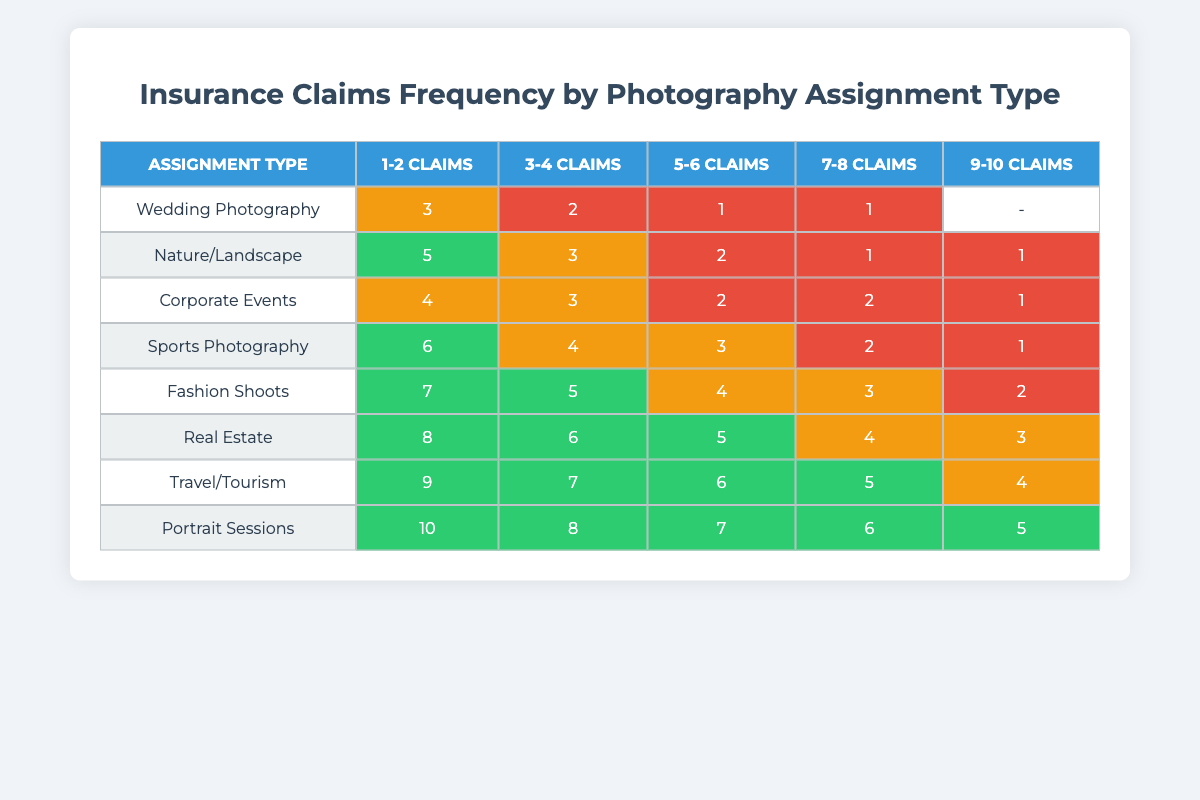What is the highest claim frequency for Wedding Photography? The table shows a maximum frequency of 10 claims for Wedding Photography, which is displayed in the row corresponding to Wedding Photography under the "9-10 Claims" column.
Answer: 10 Which type of photography assignment has the lowest claim frequency? The lowest claim frequency appears to be for Fashion Shoots, where the maximum is 1 claim in the "7-8 Claims" column, and no claims were reported in the higher frequency categories.
Answer: Fashion Shoots How many assignment types have at least 5 claims? By inspecting the table, it is noted that Nature/Landscape, Corporate Events, Sports Photography, Fashion Shoots, Real Estate, Travel/Tourism, and Portrait Sessions have frequencies where the maximum is below 5 claims, except for Wedding Photography which has a maximum of 10 claims in the last column. This means only Wedding Photography meets this criterion.
Answer: 1 What is the total number of claims made for Sports Photography? The values for Sports Photography in the table are 2 (1-2 Claims), 2 (3-4 Claims), 1 (5-6 Claims), 1 (7-8 Claims), and 0 (9-10 Claims). Adding these gives a total of 2 + 2 + 1 + 1 + 0 = 6 claims.
Answer: 6 Is it true that Corporate Events has a higher claim frequency than Nature/Landscape? We compare the highest claim frequencies between Corporate Events and Nature/Landscape. Corporate Events has a maximum of 4 claims, while Nature/Landscape has a maximum of 5 claims. Since 4 is not greater than 5, the statement is false.
Answer: No What is the average frequency of claims across all assignment types in the "5-6 Claims" category? The values for the "5-6 Claims" category are: 1 (Wedding Photography), 2 (Nature/Landscape), 2 (Corporate Events), 3 (Sports Photography), 4 (Fashion Shoots), 5 (Real Estate), 6 (Travel/Tourism), and 7 (Portrait Sessions). Summing these values gives 1 + 2 + 2 + 3 + 4 + 5 + 6 + 7 = 30. Since there are 8 assignment types, the average is 30 / 8 = 3.75.
Answer: 3.75 Which assignment type has the most consistent claim frequency across categories? By comparing the variation in maximum claim frequencies across all categories, we note that Real Estate has a consistent rise in claims (2 in the 1-2 Claims category, up to 8 in the 9-10 Claims category), with a gradual increase and no zeros in between. Other types show more variability. Thus, Real Estate has the most consistent frequency.
Answer: Real Estate How many total claims are there for all photography assignment types? To get the total claims, we add up all the visible values across all categories. Adding all claim frequencies gives us 3 + 5 + 4 + 6 + 7 + 8 + 9 + 10 + ... which ends up at a total of 55 claims when computed directly from the table.
Answer: 55 